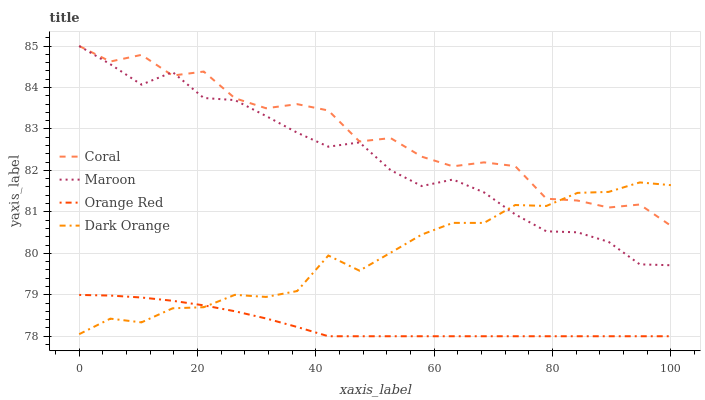Does Orange Red have the minimum area under the curve?
Answer yes or no. Yes. Does Coral have the maximum area under the curve?
Answer yes or no. Yes. Does Coral have the minimum area under the curve?
Answer yes or no. No. Does Orange Red have the maximum area under the curve?
Answer yes or no. No. Is Orange Red the smoothest?
Answer yes or no. Yes. Is Coral the roughest?
Answer yes or no. Yes. Is Coral the smoothest?
Answer yes or no. No. Is Orange Red the roughest?
Answer yes or no. No. Does Orange Red have the lowest value?
Answer yes or no. Yes. Does Coral have the lowest value?
Answer yes or no. No. Does Maroon have the highest value?
Answer yes or no. Yes. Does Orange Red have the highest value?
Answer yes or no. No. Is Orange Red less than Maroon?
Answer yes or no. Yes. Is Maroon greater than Orange Red?
Answer yes or no. Yes. Does Dark Orange intersect Orange Red?
Answer yes or no. Yes. Is Dark Orange less than Orange Red?
Answer yes or no. No. Is Dark Orange greater than Orange Red?
Answer yes or no. No. Does Orange Red intersect Maroon?
Answer yes or no. No. 